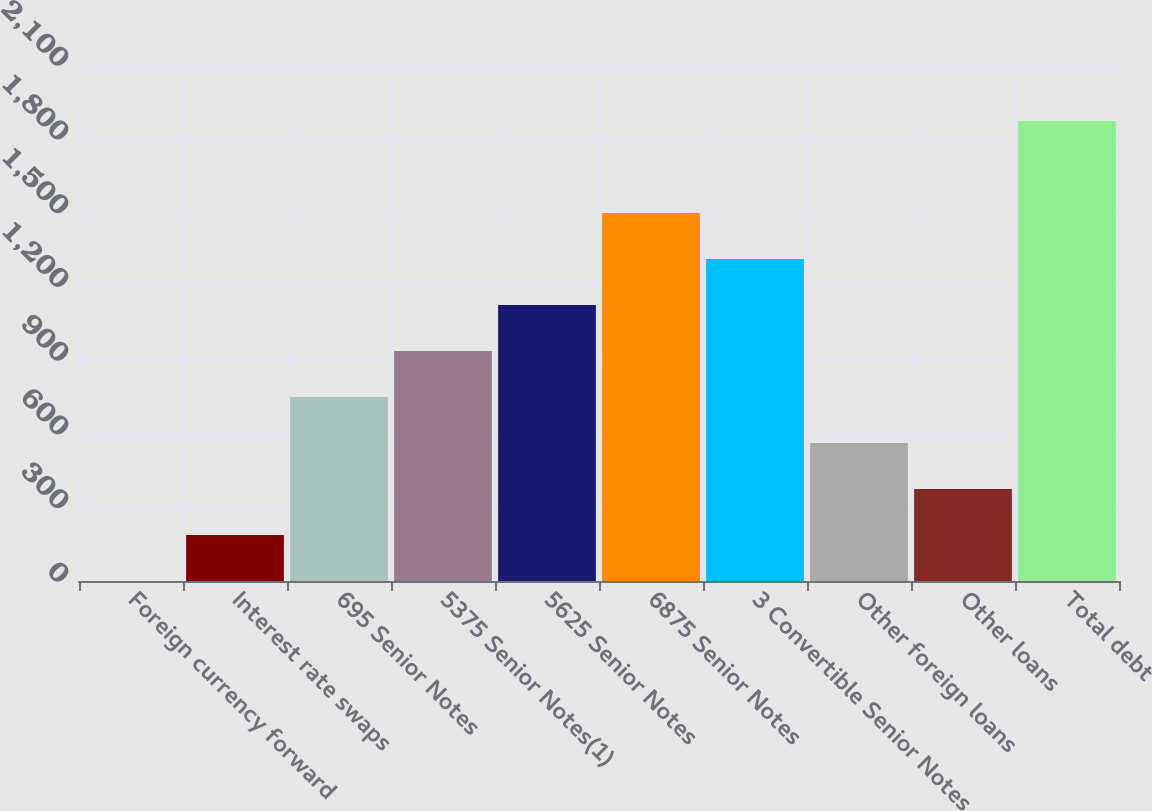Convert chart. <chart><loc_0><loc_0><loc_500><loc_500><bar_chart><fcel>Foreign currency forward<fcel>Interest rate swaps<fcel>695 Senior Notes<fcel>5375 Senior Notes(1)<fcel>5625 Senior Notes<fcel>6875 Senior Notes<fcel>3 Convertible Senior Notes<fcel>Other foreign loans<fcel>Other loans<fcel>Total debt<nl><fcel>0.5<fcel>187.63<fcel>749.02<fcel>936.15<fcel>1123.28<fcel>1497.54<fcel>1310.41<fcel>561.89<fcel>374.76<fcel>1871.8<nl></chart> 